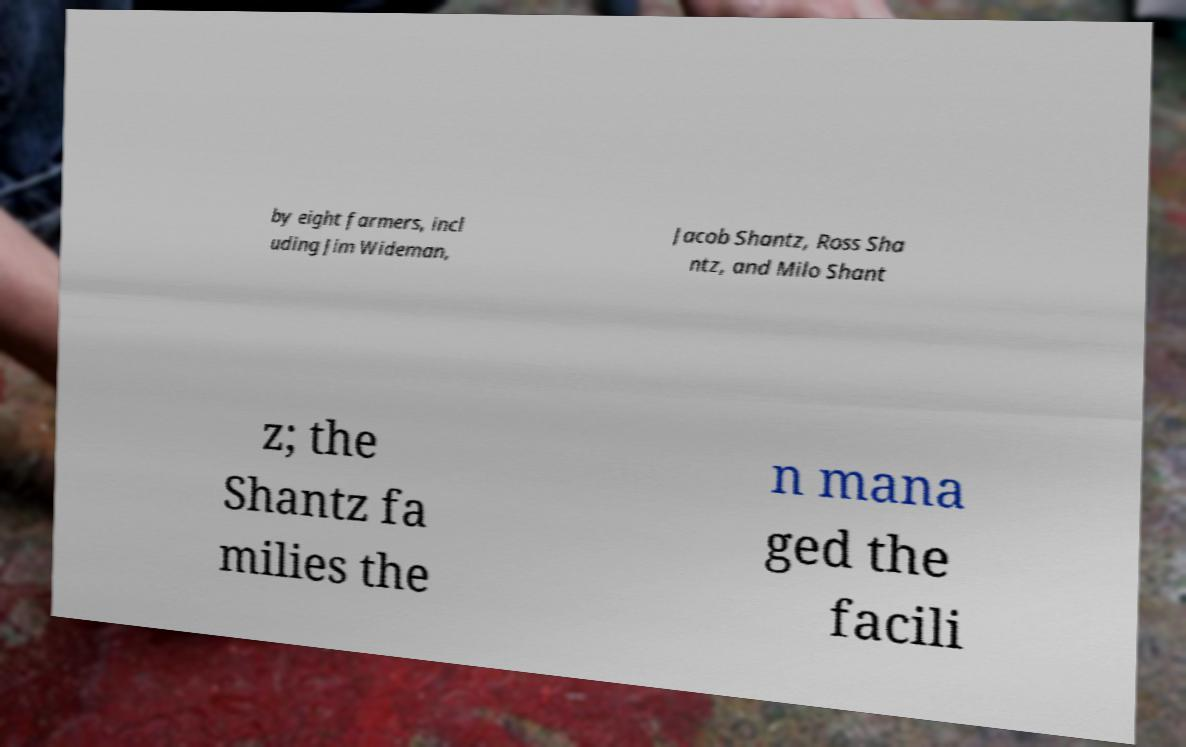There's text embedded in this image that I need extracted. Can you transcribe it verbatim? by eight farmers, incl uding Jim Wideman, Jacob Shantz, Ross Sha ntz, and Milo Shant z; the Shantz fa milies the n mana ged the facili 